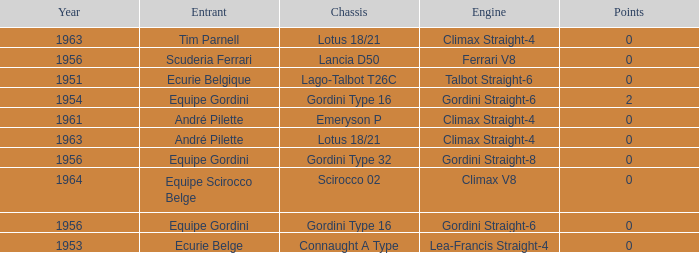Who was in 1963? Tim Parnell, André Pilette. 